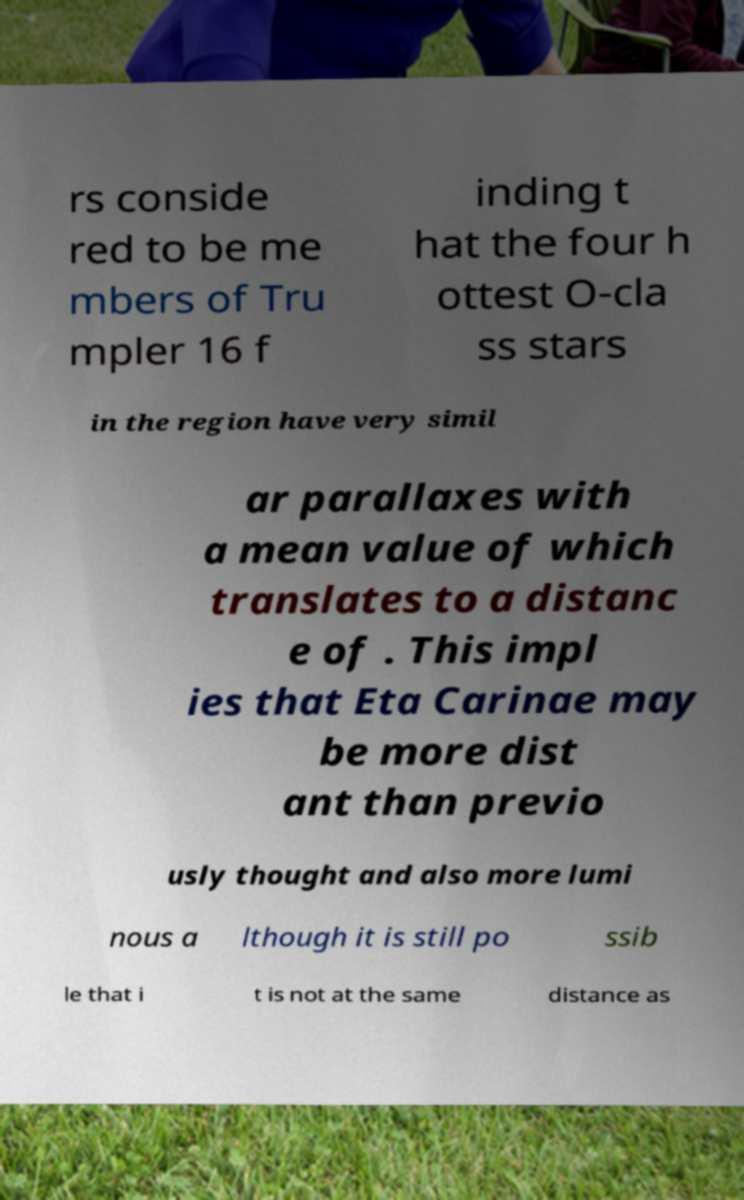Please identify and transcribe the text found in this image. rs conside red to be me mbers of Tru mpler 16 f inding t hat the four h ottest O-cla ss stars in the region have very simil ar parallaxes with a mean value of which translates to a distanc e of . This impl ies that Eta Carinae may be more dist ant than previo usly thought and also more lumi nous a lthough it is still po ssib le that i t is not at the same distance as 